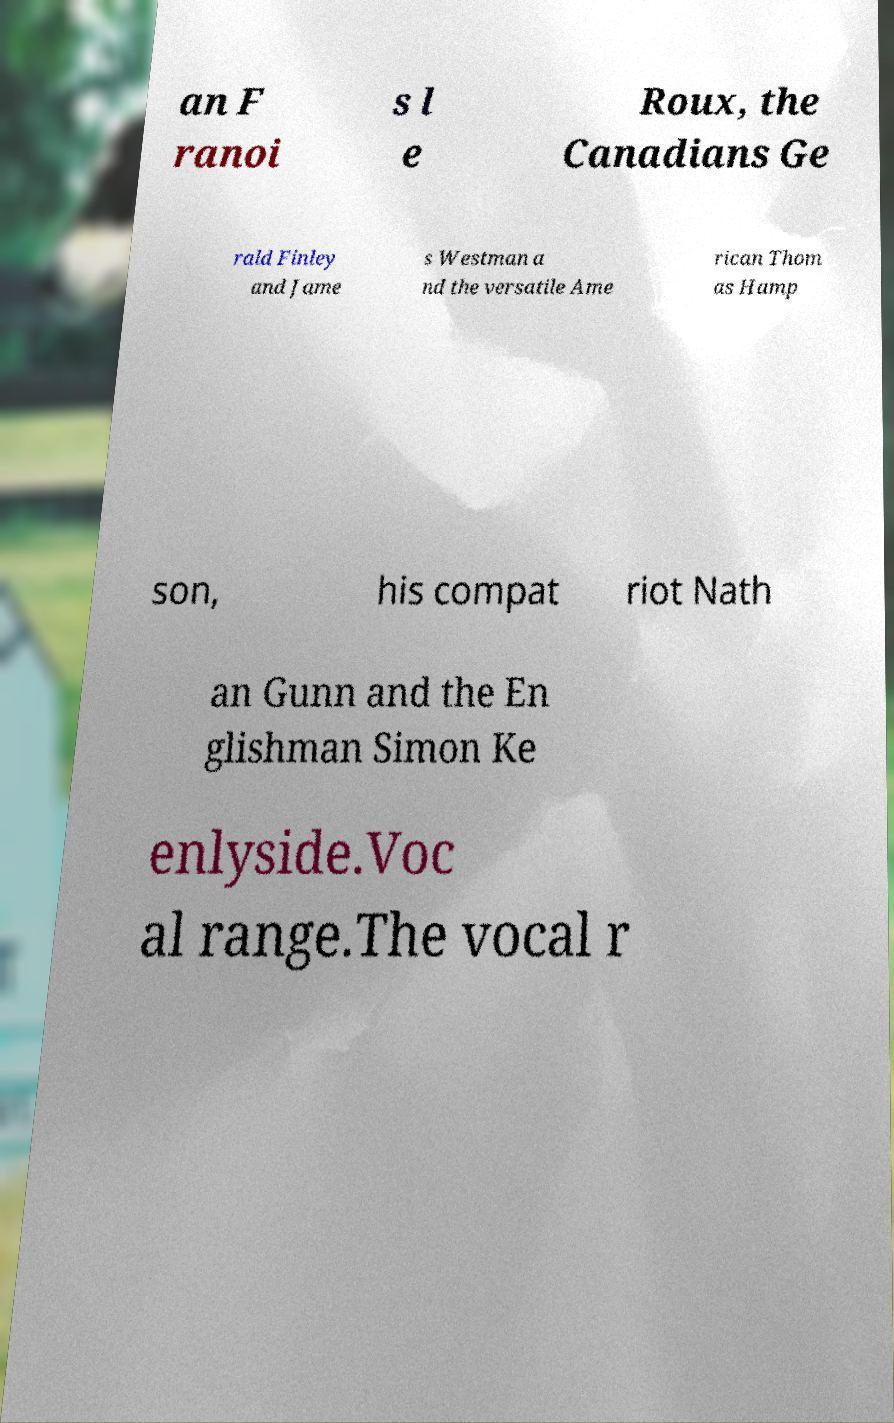What messages or text are displayed in this image? I need them in a readable, typed format. an F ranoi s l e Roux, the Canadians Ge rald Finley and Jame s Westman a nd the versatile Ame rican Thom as Hamp son, his compat riot Nath an Gunn and the En glishman Simon Ke enlyside.Voc al range.The vocal r 